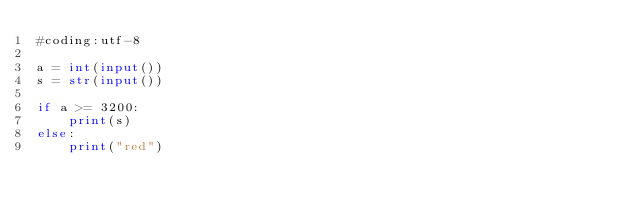Convert code to text. <code><loc_0><loc_0><loc_500><loc_500><_Python_>#coding:utf-8

a = int(input())
s = str(input())

if a >= 3200:
    print(s)
else:
    print("red")</code> 